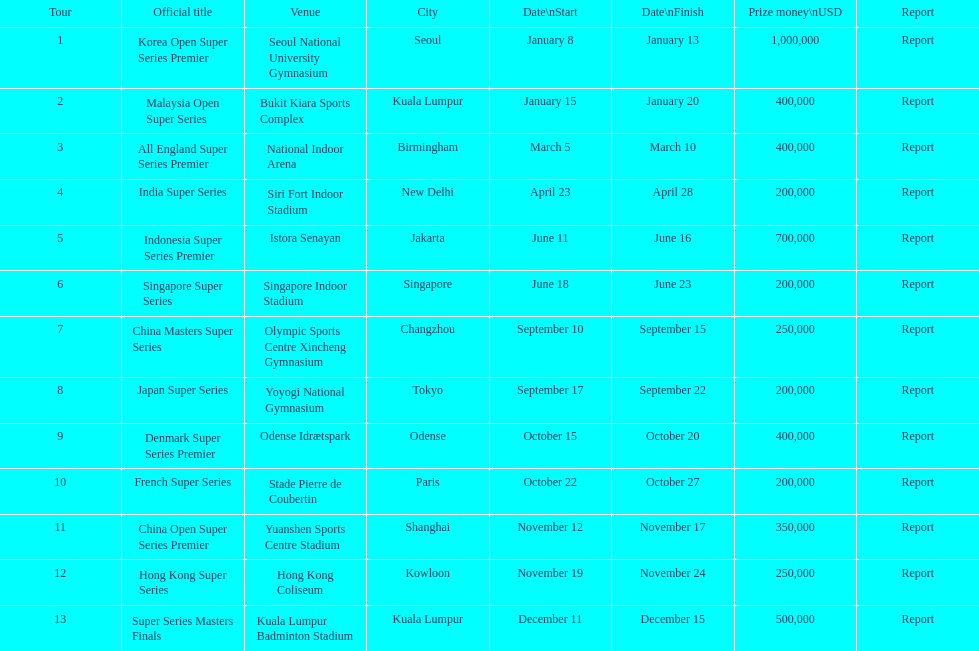How many competitions of the 2013 bwf super series award over $200,000? 9. 